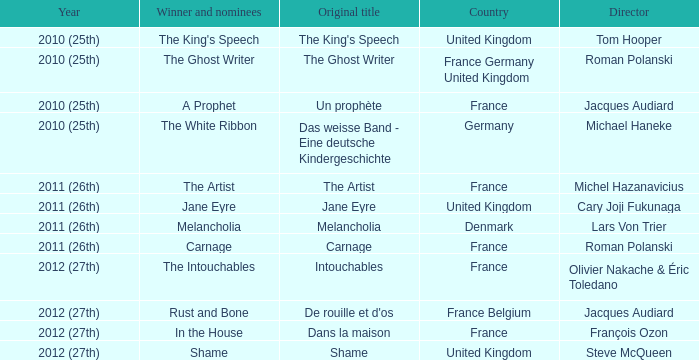What was the original title for the king's speech? The King's Speech. 